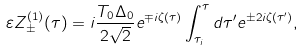Convert formula to latex. <formula><loc_0><loc_0><loc_500><loc_500>\varepsilon Z _ { \pm } ^ { ( 1 ) } ( \tau ) = i \frac { T _ { 0 } \Delta _ { 0 } } { 2 \sqrt { 2 } } e ^ { \mp i \zeta ( \tau ) } \int _ { \tau _ { i } } ^ { \tau } d \tau ^ { \prime } e ^ { \pm 2 i \zeta ( \tau ^ { \prime } ) } ,</formula> 